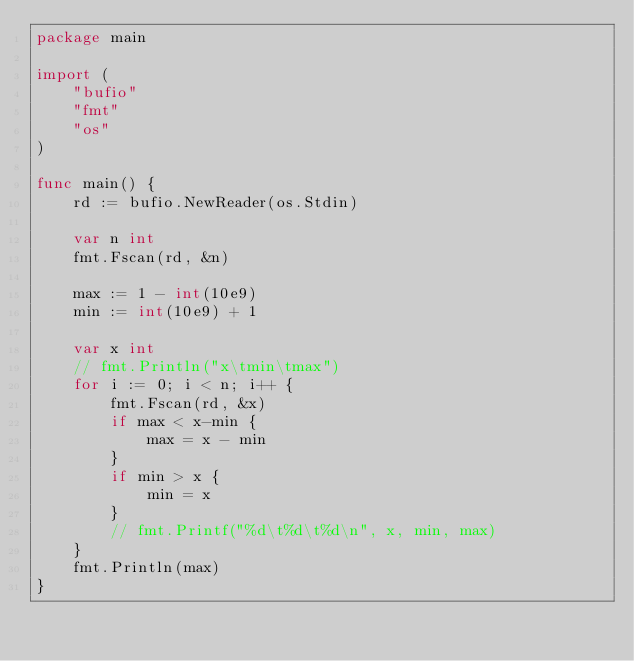Convert code to text. <code><loc_0><loc_0><loc_500><loc_500><_Go_>package main

import (
	"bufio"
	"fmt"
	"os"
)

func main() {
	rd := bufio.NewReader(os.Stdin)

	var n int
	fmt.Fscan(rd, &n)

	max := 1 - int(10e9)
	min := int(10e9) + 1

	var x int
	// fmt.Println("x\tmin\tmax")
	for i := 0; i < n; i++ {
		fmt.Fscan(rd, &x)
		if max < x-min {
			max = x - min
		}
		if min > x {
			min = x
		}
		// fmt.Printf("%d\t%d\t%d\n", x, min, max)
	}
	fmt.Println(max)
}

</code> 